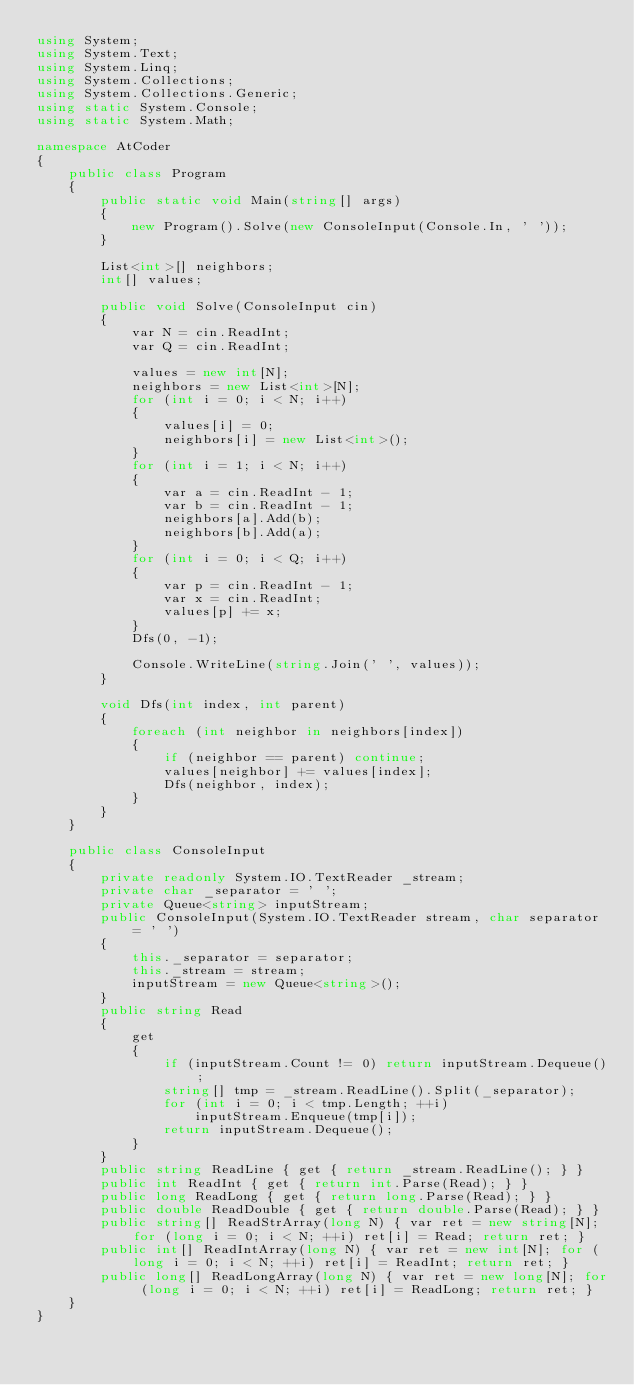Convert code to text. <code><loc_0><loc_0><loc_500><loc_500><_C#_>using System;
using System.Text;
using System.Linq;
using System.Collections;
using System.Collections.Generic;
using static System.Console;
using static System.Math;

namespace AtCoder
{
    public class Program
    {
        public static void Main(string[] args)
        {
            new Program().Solve(new ConsoleInput(Console.In, ' '));
        }

        List<int>[] neighbors;
        int[] values;

        public void Solve(ConsoleInput cin)
        {
            var N = cin.ReadInt;
            var Q = cin.ReadInt;

            values = new int[N];
            neighbors = new List<int>[N];
            for (int i = 0; i < N; i++)
            {
                values[i] = 0;
                neighbors[i] = new List<int>();
            }
            for (int i = 1; i < N; i++)
            {
                var a = cin.ReadInt - 1;
                var b = cin.ReadInt - 1;
                neighbors[a].Add(b);
                neighbors[b].Add(a);
            }
            for (int i = 0; i < Q; i++)
            {
                var p = cin.ReadInt - 1;
                var x = cin.ReadInt;
                values[p] += x;
            }
            Dfs(0, -1);

            Console.WriteLine(string.Join(' ', values));
        }

        void Dfs(int index, int parent)
        {
            foreach (int neighbor in neighbors[index])
            {
                if (neighbor == parent) continue;
                values[neighbor] += values[index];
                Dfs(neighbor, index);
            }
        }
    }

    public class ConsoleInput
    {
        private readonly System.IO.TextReader _stream;
        private char _separator = ' ';
        private Queue<string> inputStream;
        public ConsoleInput(System.IO.TextReader stream, char separator = ' ')
        {
            this._separator = separator;
            this._stream = stream;
            inputStream = new Queue<string>();
        }
        public string Read
        {
            get
            {
                if (inputStream.Count != 0) return inputStream.Dequeue();
                string[] tmp = _stream.ReadLine().Split(_separator);
                for (int i = 0; i < tmp.Length; ++i)
                    inputStream.Enqueue(tmp[i]);
                return inputStream.Dequeue();
            }
        }
        public string ReadLine { get { return _stream.ReadLine(); } }
        public int ReadInt { get { return int.Parse(Read); } }
        public long ReadLong { get { return long.Parse(Read); } }
        public double ReadDouble { get { return double.Parse(Read); } }
        public string[] ReadStrArray(long N) { var ret = new string[N]; for (long i = 0; i < N; ++i) ret[i] = Read; return ret; }
        public int[] ReadIntArray(long N) { var ret = new int[N]; for (long i = 0; i < N; ++i) ret[i] = ReadInt; return ret; }
        public long[] ReadLongArray(long N) { var ret = new long[N]; for (long i = 0; i < N; ++i) ret[i] = ReadLong; return ret; }
    }
}</code> 